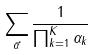Convert formula to latex. <formula><loc_0><loc_0><loc_500><loc_500>\sum _ { \vec { \alpha } } \frac { 1 } { \prod _ { k = 1 } ^ { K } \alpha _ { k } }</formula> 